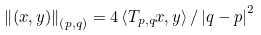Convert formula to latex. <formula><loc_0><loc_0><loc_500><loc_500>\left \| \left ( x , y \right ) \right \| _ { \left ( p , q \right ) } = 4 \left \langle T _ { p , q } x , y \right \rangle / \left | q - p \right | ^ { 2 }</formula> 